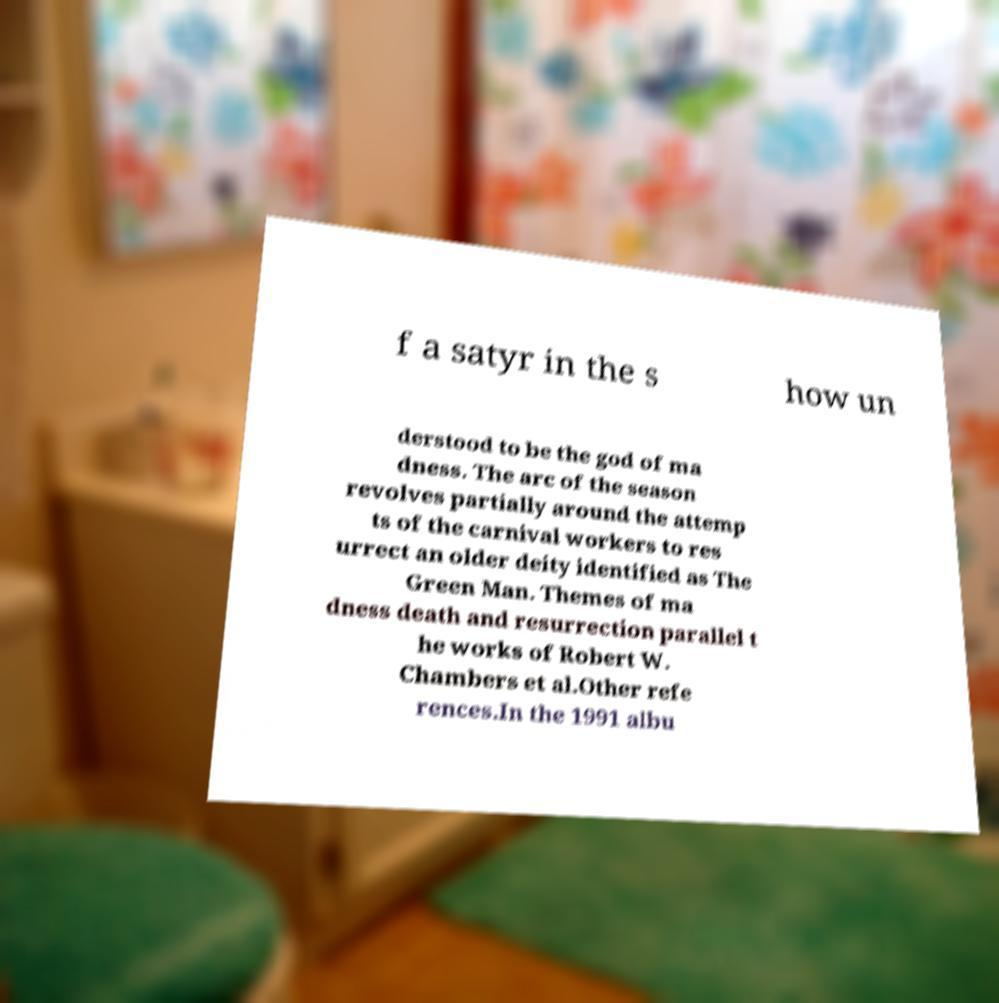Could you extract and type out the text from this image? f a satyr in the s how un derstood to be the god of ma dness. The arc of the season revolves partially around the attemp ts of the carnival workers to res urrect an older deity identified as The Green Man. Themes of ma dness death and resurrection parallel t he works of Robert W. Chambers et al.Other refe rences.In the 1991 albu 